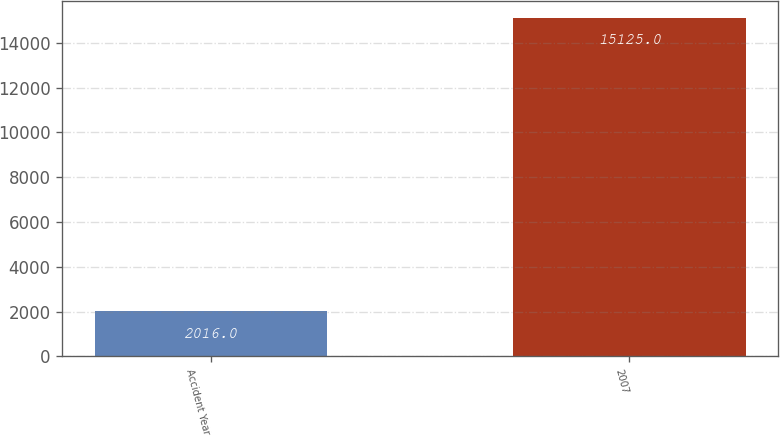Convert chart. <chart><loc_0><loc_0><loc_500><loc_500><bar_chart><fcel>Accident Year<fcel>2007<nl><fcel>2016<fcel>15125<nl></chart> 